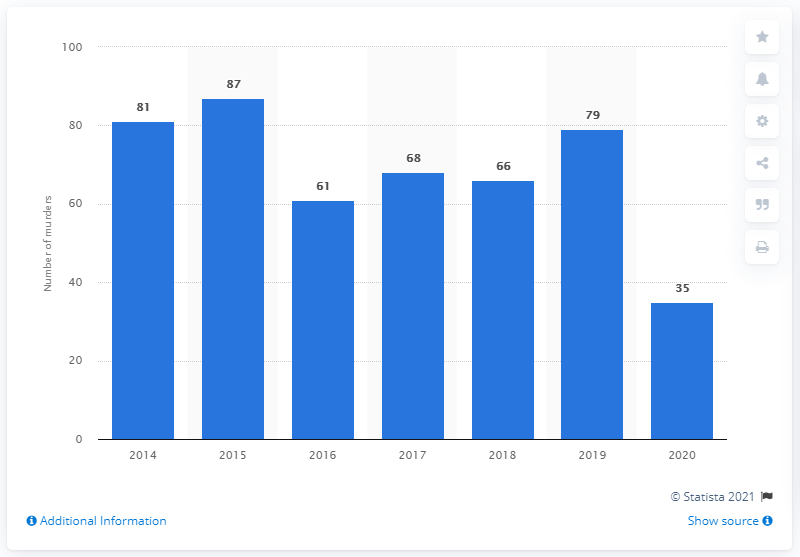Indicate a few pertinent items in this graphic. In 2020, a total of 35 murders were committed in Port of Spain. 